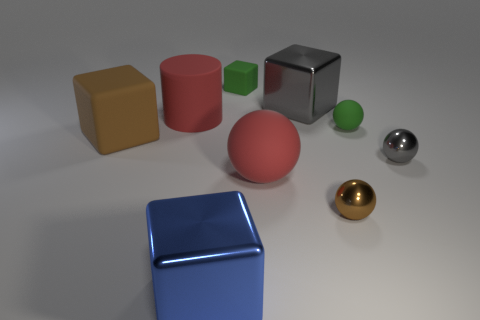There is a cylinder that is the same color as the big ball; what is its size?
Offer a very short reply. Large. Do the small rubber thing behind the large cylinder and the cylinder have the same color?
Give a very brief answer. No. What number of objects are behind the matte object that is behind the red matte thing on the left side of the blue metal block?
Your response must be concise. 0. How many big things are to the left of the large blue block and behind the large brown rubber cube?
Offer a terse response. 1. What shape is the small object that is the same color as the small matte ball?
Your response must be concise. Cube. Is there any other thing that is the same material as the large gray object?
Keep it short and to the point. Yes. Do the green cube and the big gray thing have the same material?
Provide a short and direct response. No. The green object left of the big matte thing that is in front of the gray sphere that is to the right of the large gray thing is what shape?
Offer a terse response. Cube. Are there fewer tiny gray objects left of the green sphere than big brown matte cubes that are behind the small brown metallic sphere?
Give a very brief answer. Yes. What is the shape of the matte object that is on the right side of the red rubber thing on the right side of the big blue shiny thing?
Offer a terse response. Sphere. 